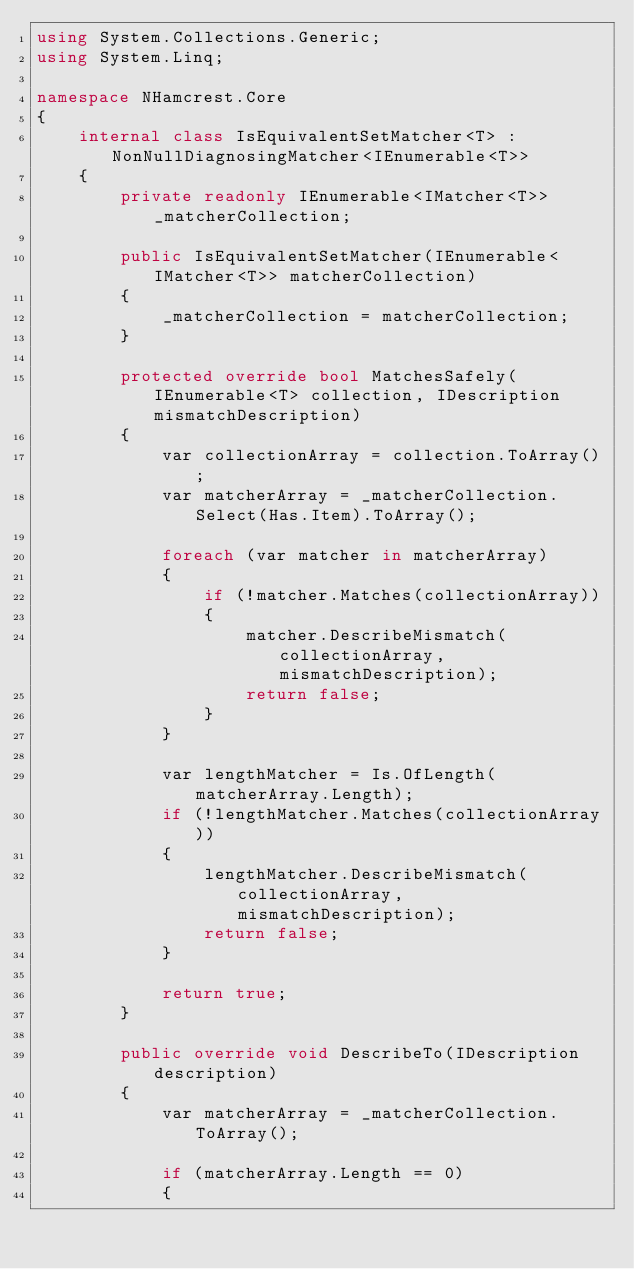<code> <loc_0><loc_0><loc_500><loc_500><_C#_>using System.Collections.Generic;
using System.Linq;

namespace NHamcrest.Core
{
    internal class IsEquivalentSetMatcher<T> : NonNullDiagnosingMatcher<IEnumerable<T>>
    {
        private readonly IEnumerable<IMatcher<T>> _matcherCollection;

        public IsEquivalentSetMatcher(IEnumerable<IMatcher<T>> matcherCollection)
        {
            _matcherCollection = matcherCollection;
        }

        protected override bool MatchesSafely(IEnumerable<T> collection, IDescription mismatchDescription)
        {
            var collectionArray = collection.ToArray();
            var matcherArray = _matcherCollection.Select(Has.Item).ToArray();

            foreach (var matcher in matcherArray)
            {
                if (!matcher.Matches(collectionArray))
                {
                    matcher.DescribeMismatch(collectionArray, mismatchDescription);
                    return false;
                }
            }

            var lengthMatcher = Is.OfLength(matcherArray.Length);
            if (!lengthMatcher.Matches(collectionArray))
            {
                lengthMatcher.DescribeMismatch(collectionArray, mismatchDescription);
                return false;
            }

            return true;
        }

        public override void DescribeTo(IDescription description)
        {
            var matcherArray = _matcherCollection.ToArray();

            if (matcherArray.Length == 0)
            {</code> 